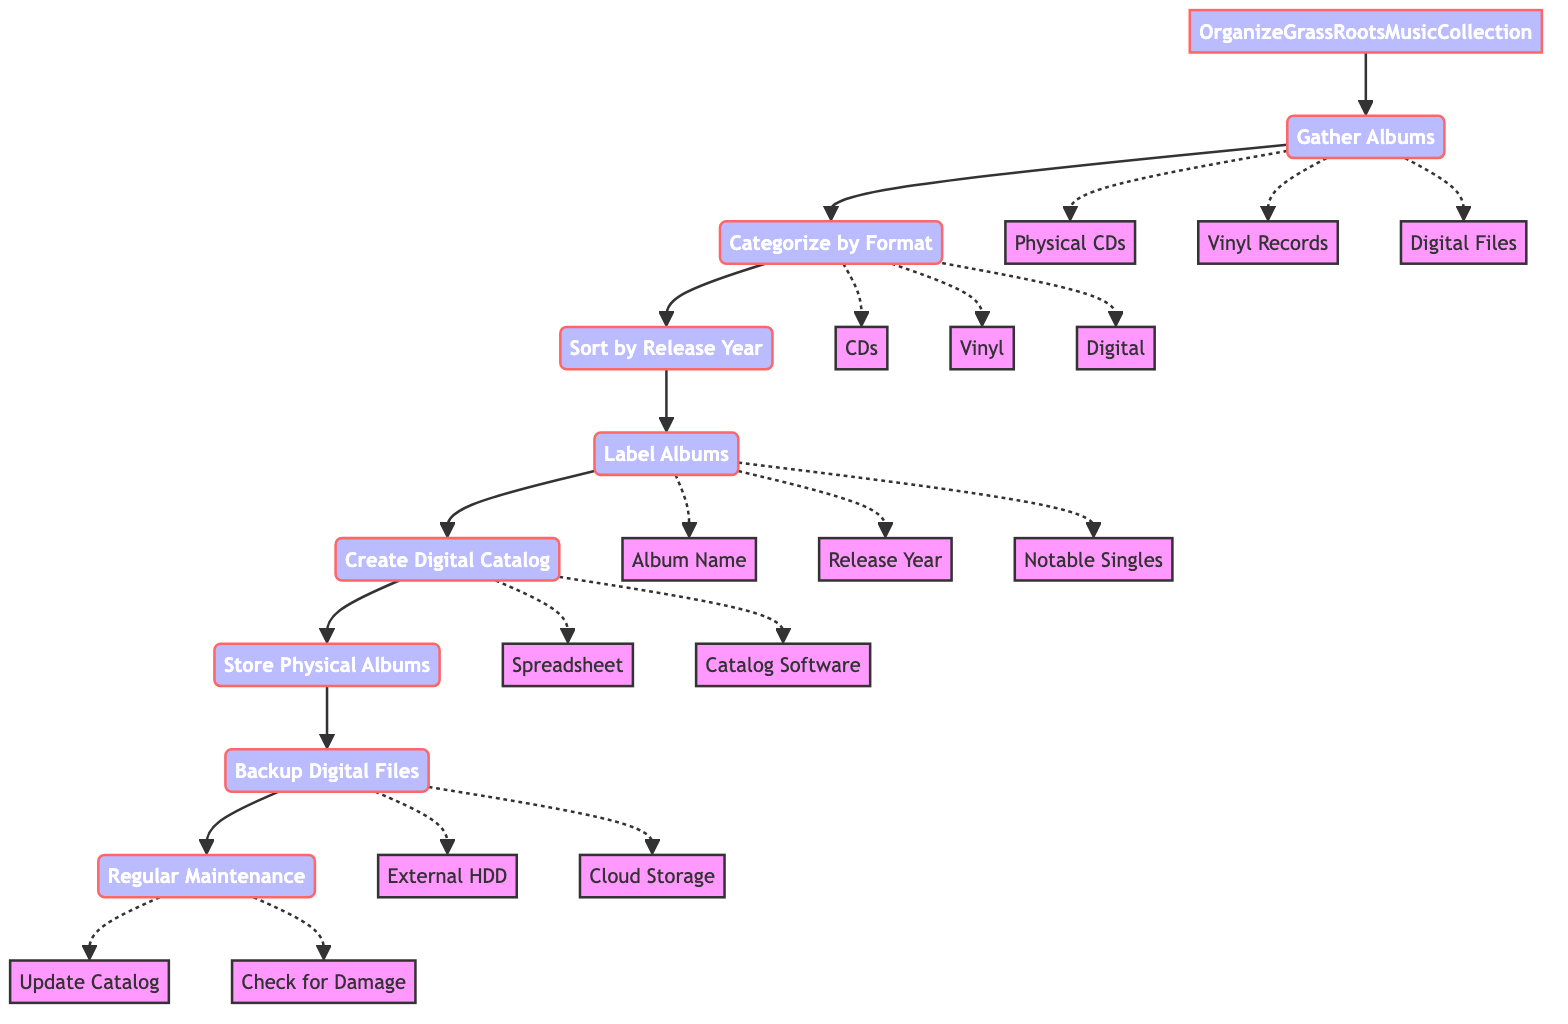What is the first step in the process? The first step is indicated as "Gather Albums," which is the starting node in the flowchart.
Answer: Gather Albums How many total steps are in the process? The diagram outlines a total of eight steps, as seen from the nodes leading from "OrganizeGrassRootsMusicCollection" to "Regular Maintenance."
Answer: Eight What format categories are mentioned in the diagram? The categories are listed as CDs, Vinyl Records, and Digital Files, which are the distinct formats mentioned in the sorting step.
Answer: CDs, Vinyl Records, Digital Files What is done after categorizing albums by format? The following step after categorization is sorting the albums by their release year, as indicated by the arrow leading from the categorization step to the sorting step.
Answer: Sort by Release Year What additional details are included when labeling albums? The details specified for labeling include the album name, release year, and notable singles, as per the information linked to the labeling node.
Answer: Album Name, Release Year, Notable Singles What happens during the backup step? The backup step emphasizes using an external hard drive or cloud storage for the digital music files, which are necessary for safeguarding the collection.
Answer: External Hard Drive, Cloud Storage How is the digital catalog created? It can be created using either a spreadsheet or music catalog software, as indicated in the step associated with creating the digital catalog.
Answer: Spreadsheet, Music Catalog Software What maintenance is suggested for the collection? Regular maintenance includes updating the catalog with new acquisitions and checking for any physical damage or digital file corruption, as specified in the final maintenance step.
Answer: Update Catalog, Check for Damage 